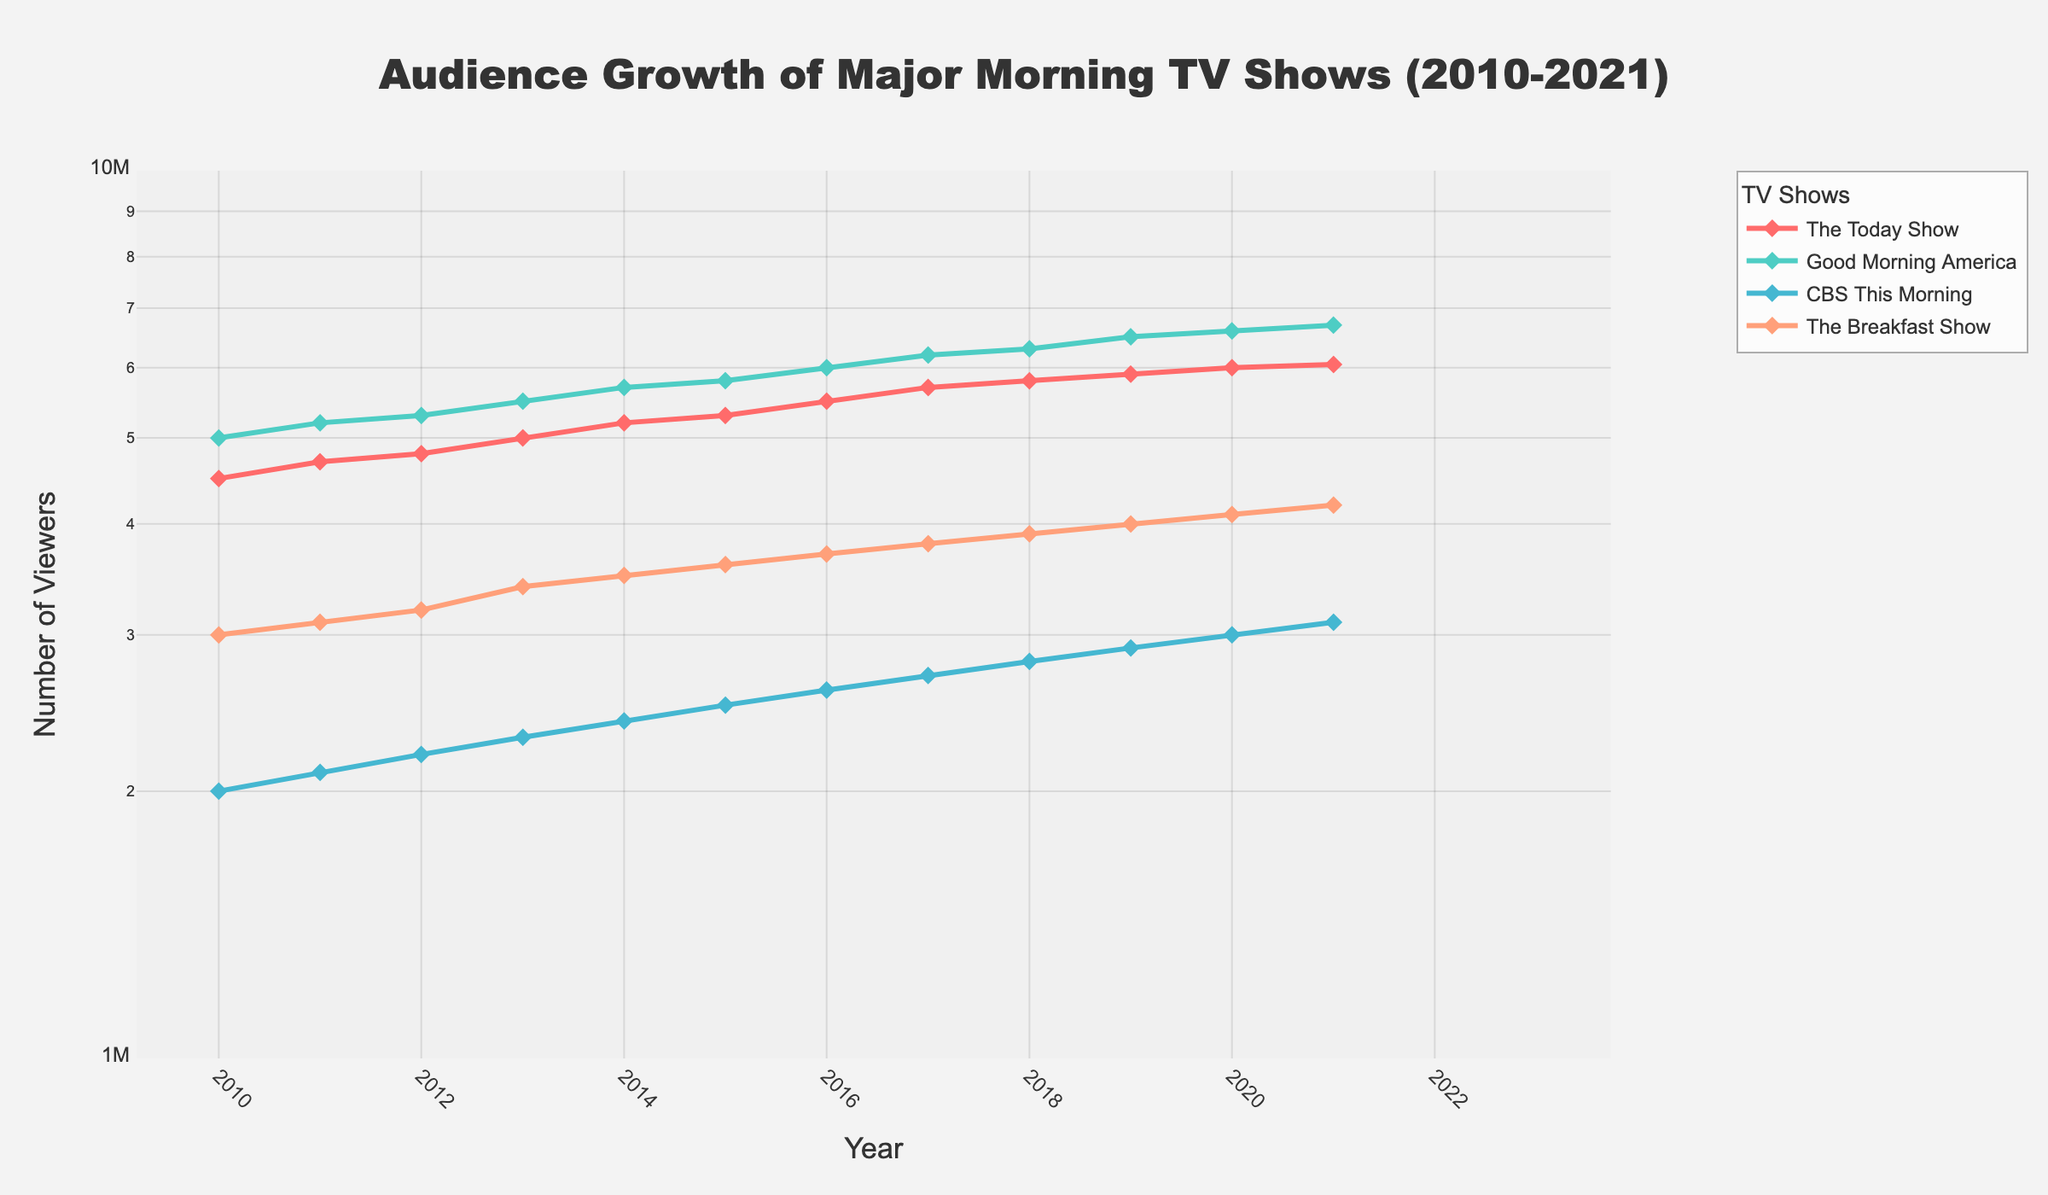What's the title of the figure? The title is located at the top of the figure and is clearly labeled.
Answer: Audience Growth of Major Morning TV Shows (2010-2021) How many TV shows are represented in the figure? Observe the legend or the number of traces (lines) in the plot.
Answer: Four Which TV show has the lowest audience in 2010? Look at the starting points of the curves on the y-axis for 2010 and identify the lowest value.
Answer: CBS This Morning Between 2016 and 2021, which TV show had the highest growth rate? Compare the steepness of the lines between these years. The steepest line represents the highest growth rate.
Answer: The Breakfast Show What is the color used to represent 'Good Morning America'? Check the line or point colors in the legend or on the plot.
Answer: Teal What is the approximate audience size for 'The Today Show' in 2015? Find the point on the graph where 'The Today Show' intersects with the year 2015.
Answer: Around 5,300,000 Which show had the smallest audience increase from 2010 to 2021? Calculate the difference from 2010 to 2021 for all shows and identify the smallest increase.
Answer: CBS This Morning Which two TV shows had nearly parallel audience growth trends? Compare the slopes of the lines for different shows and check for parallelism.
Answer: The Today Show and Good Morning America Estimate the number of viewers 'The Breakfast Show' had in 2018? Locate 'The Breakfast Show' line in 2018 and read the y-axis value.
Answer: Around 3,900,000 What is the y-axis range in the plot? Read the minimum and maximum values on the y-axis.
Answer: 1,000,000 to 10,000,000 